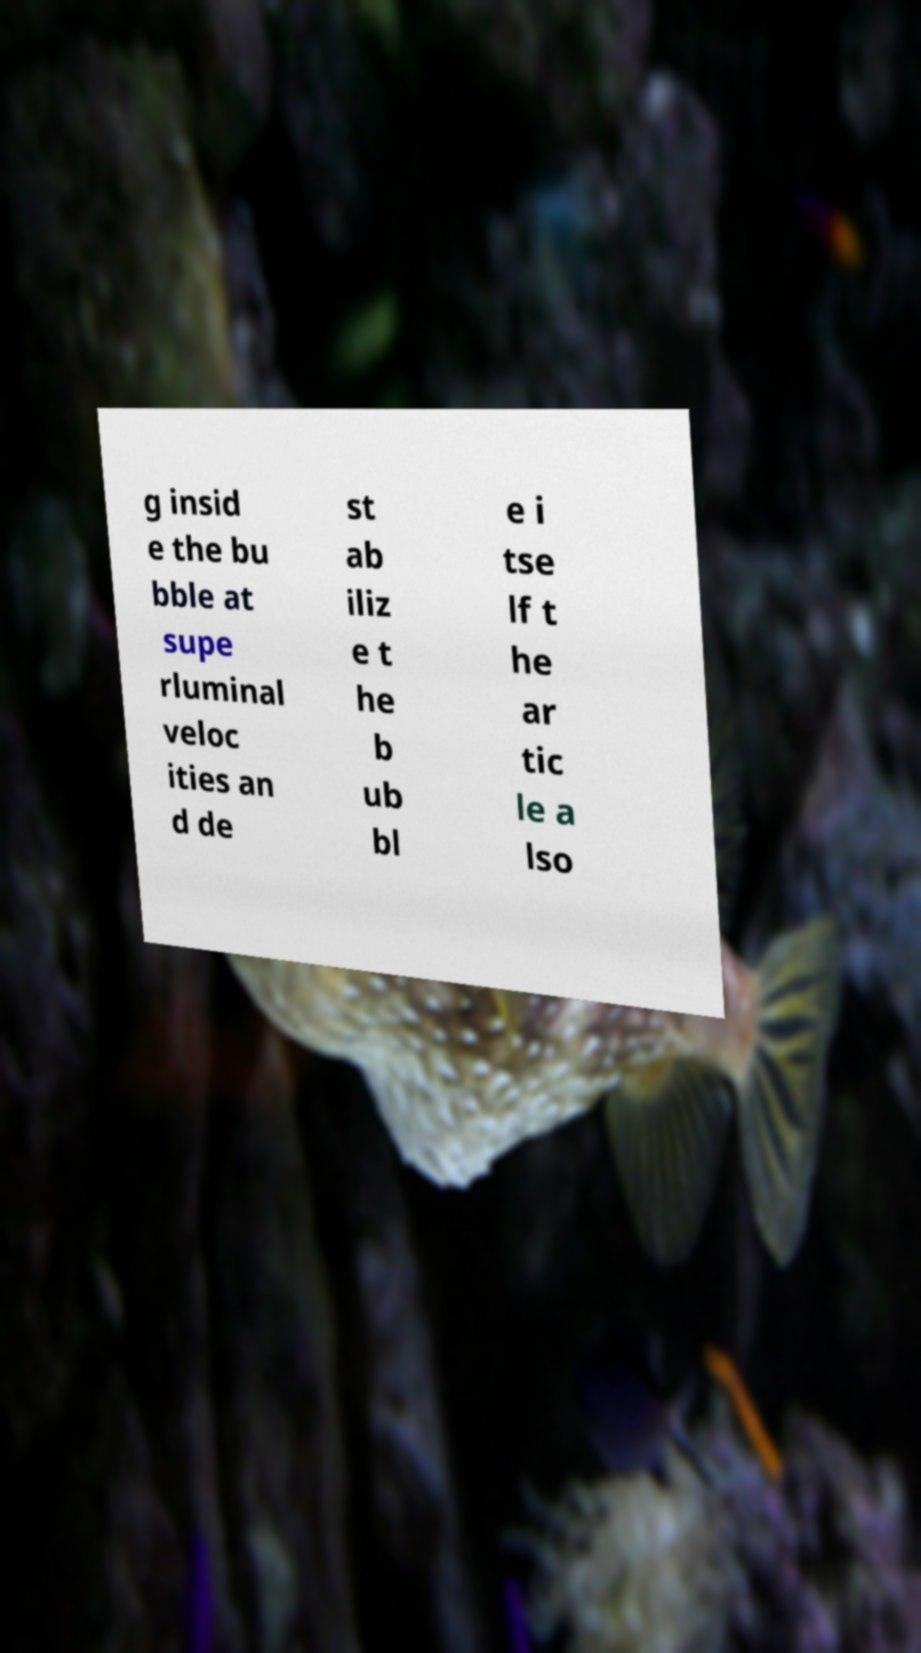Can you accurately transcribe the text from the provided image for me? g insid e the bu bble at supe rluminal veloc ities an d de st ab iliz e t he b ub bl e i tse lf t he ar tic le a lso 